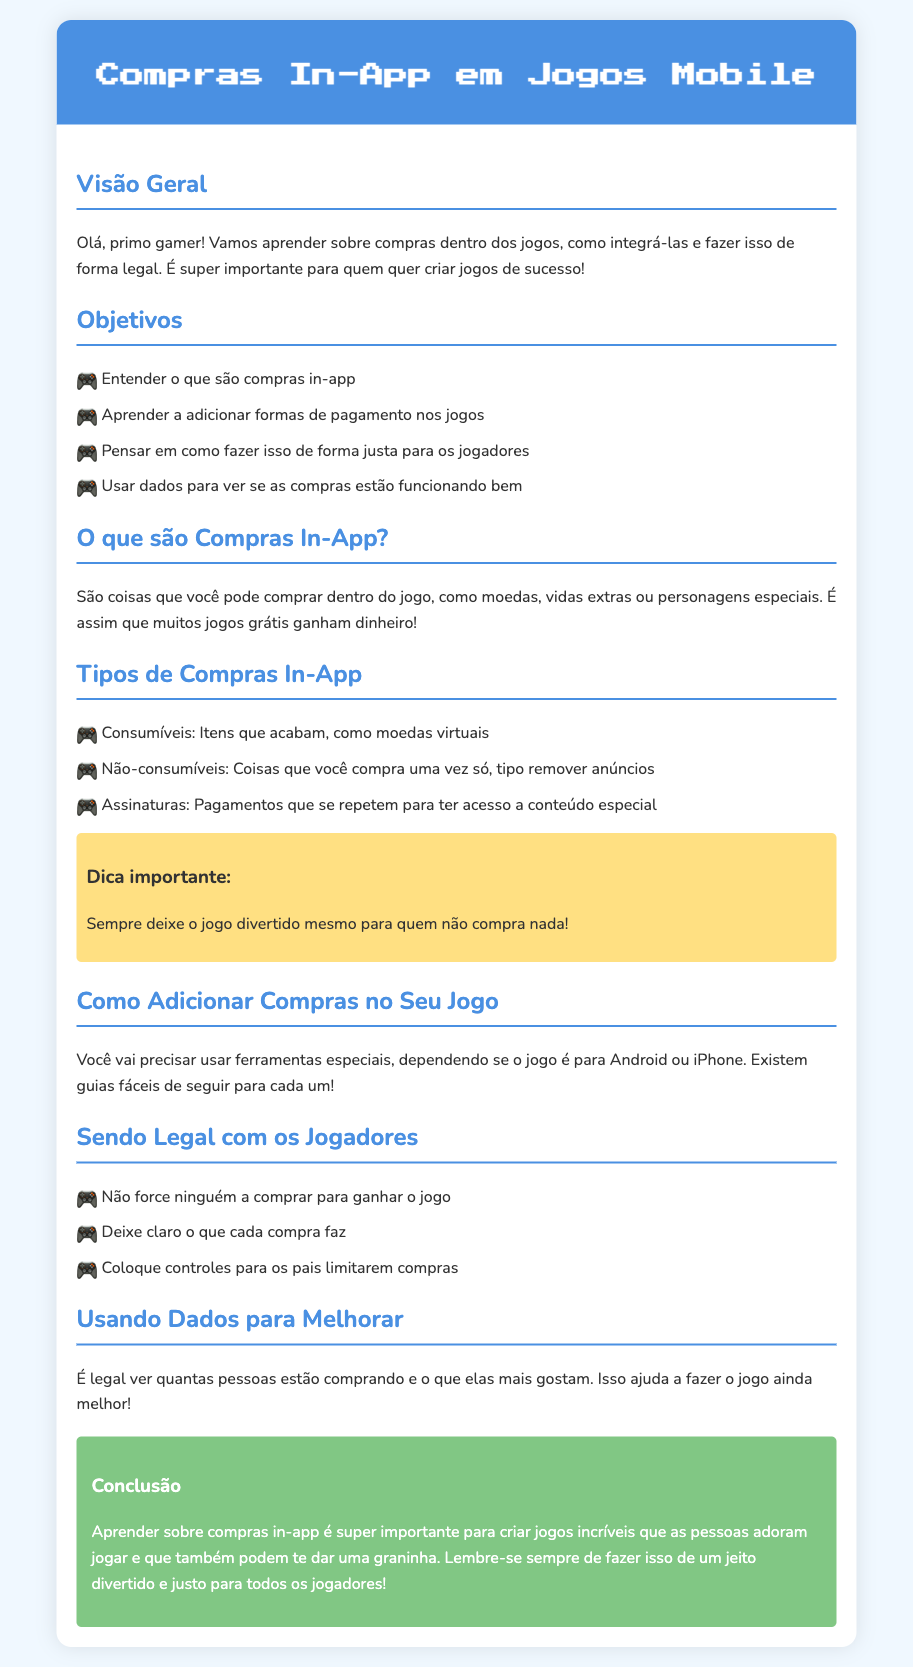Qual é o título do documento? O título está explicitamente mencionado no cabeçalho do documento.
Answer: Compras In-App em Jogos Mobile Quantos tipos de compras in-app são mencionados? O número de tipos de compras in-app é listado na seção correspondente.
Answer: três O que são itens consumíveis? A definição de itens consumíveis é fornecida na seção sobre tipos de compras in-app.
Answer: Itens que acabam, como moedas virtuais Qual é a dica importante destacada no documento? A dica importante está apresentada em uma seção específica com destaque.
Answer: Sempre deixe o jogo divertido mesmo para quem não compra nada! Qual é um dos objetivos do documento? Os objetivos estão listados na seção correspondente do documento.
Answer: Aprender a adicionar formas de pagamento nos jogos O que deve ser evitado em relação aos jogadores? O que deve ser evitado está listado na seção "Sendo Legal com os Jogadores".
Answer: Não force ninguém a comprar para ganhar o jogo O que é sugerido para os pais? A sugestão para os pais é mencionada na parte sobre sendo legal com os jogadores.
Answer: Coloque controles para os pais limitarem compras Como os dados ajudam a melhorar o jogo? A seção sobre o uso de dados explica como isso acontece.
Answer: Ajuda a fazer o jogo ainda melhor 